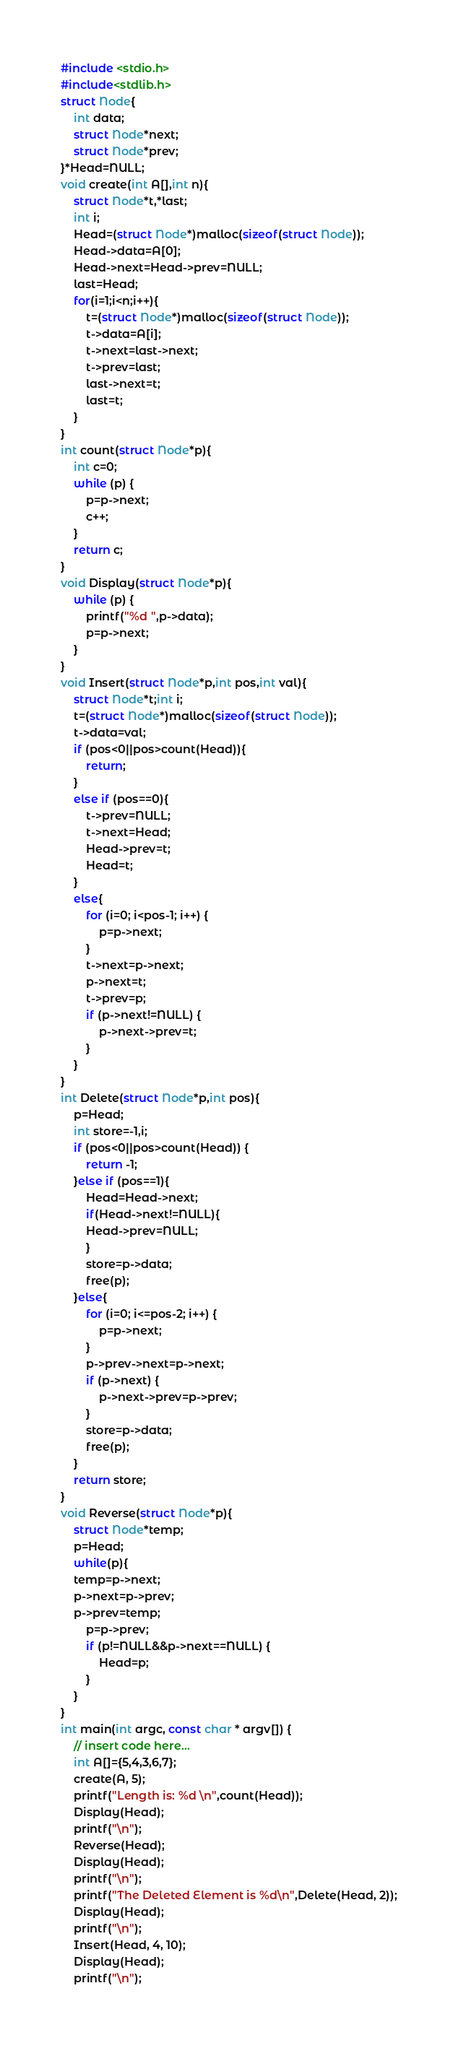Convert code to text. <code><loc_0><loc_0><loc_500><loc_500><_C_>
#include <stdio.h>
#include<stdlib.h>
struct Node{
    int data;
    struct Node*next;
    struct Node*prev;
}*Head=NULL;
void create(int A[],int n){
    struct Node*t,*last;
    int i;
    Head=(struct Node*)malloc(sizeof(struct Node));
    Head->data=A[0];
    Head->next=Head->prev=NULL;
    last=Head;
    for(i=1;i<n;i++){
        t=(struct Node*)malloc(sizeof(struct Node));
        t->data=A[i];
        t->next=last->next;
        t->prev=last;
        last->next=t;
        last=t;
    }
}
int count(struct Node*p){
    int c=0;
    while (p) {
        p=p->next;
        c++;
    }
    return c;
}
void Display(struct Node*p){
    while (p) {
        printf("%d ",p->data);
        p=p->next;
    }
}
void Insert(struct Node*p,int pos,int val){
    struct Node*t;int i;
    t=(struct Node*)malloc(sizeof(struct Node));
    t->data=val;
    if (pos<0||pos>count(Head)){
        return;
    }
    else if (pos==0){
        t->prev=NULL;
        t->next=Head;
        Head->prev=t;
        Head=t;
    }
    else{
        for (i=0; i<pos-1; i++) {
            p=p->next;
        }
        t->next=p->next;
        p->next=t;
        t->prev=p;
        if (p->next!=NULL) {
            p->next->prev=t;
        }
    }
}
int Delete(struct Node*p,int pos){
    p=Head;
    int store=-1,i;
    if (pos<0||pos>count(Head)) {
        return -1;
    }else if (pos==1){
        Head=Head->next;
        if(Head->next!=NULL){
        Head->prev=NULL;
        }
        store=p->data;
        free(p);
    }else{
        for (i=0; i<=pos-2; i++) {
            p=p->next;
        }
        p->prev->next=p->next;
        if (p->next) {
            p->next->prev=p->prev;
        }
        store=p->data;
        free(p);
    }
    return store;
}
void Reverse(struct Node*p){
    struct Node*temp;
    p=Head;
    while(p){
    temp=p->next;
    p->next=p->prev;
    p->prev=temp;
        p=p->prev;
        if (p!=NULL&&p->next==NULL) {
            Head=p;
        }
    }
}
int main(int argc, const char * argv[]) {
    // insert code here...
    int A[]={5,4,3,6,7};
    create(A, 5);
    printf("Length is: %d \n",count(Head));
    Display(Head);
    printf("\n");
    Reverse(Head);
    Display(Head);
    printf("\n");
    printf("The Deleted Element is %d\n",Delete(Head, 2));
    Display(Head);
    printf("\n");
    Insert(Head, 4, 10);
    Display(Head);
    printf("\n");</code> 